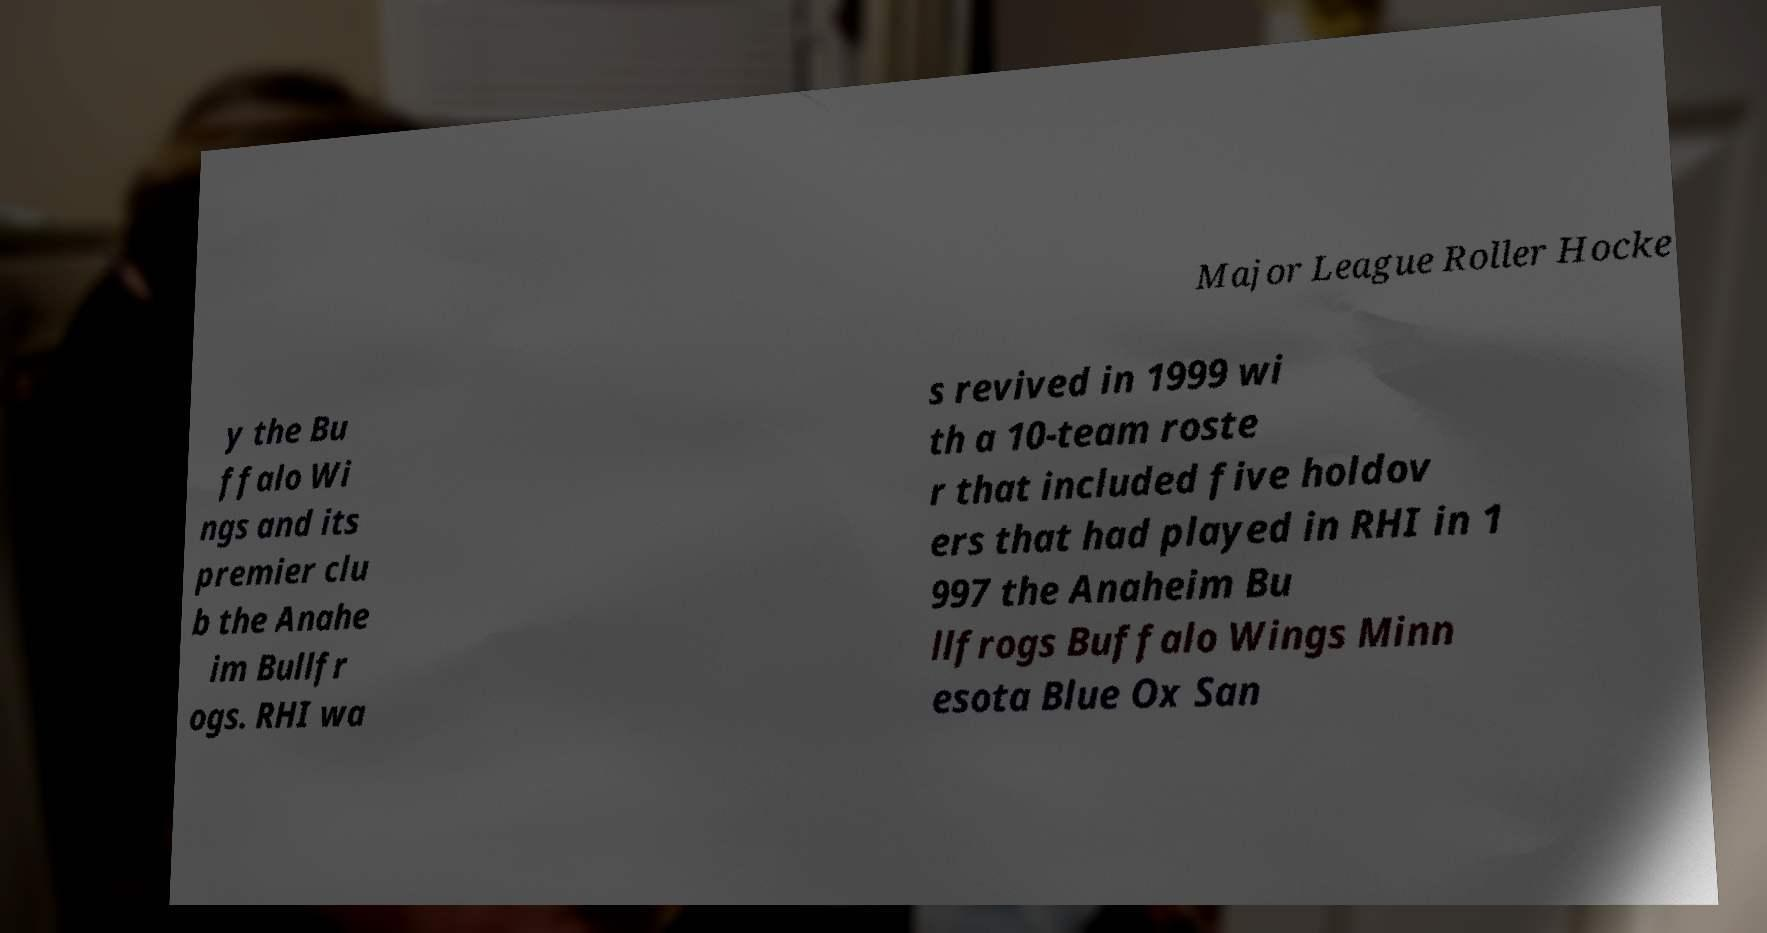What messages or text are displayed in this image? I need them in a readable, typed format. Major League Roller Hocke y the Bu ffalo Wi ngs and its premier clu b the Anahe im Bullfr ogs. RHI wa s revived in 1999 wi th a 10-team roste r that included five holdov ers that had played in RHI in 1 997 the Anaheim Bu llfrogs Buffalo Wings Minn esota Blue Ox San 